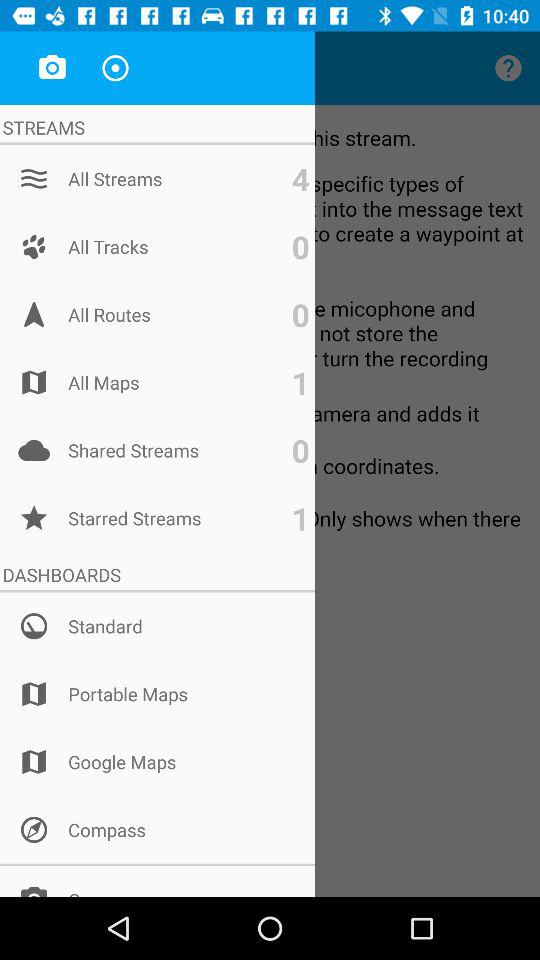What is the number of items in "All Streams"? The number of items in "All Streams" is 4. 